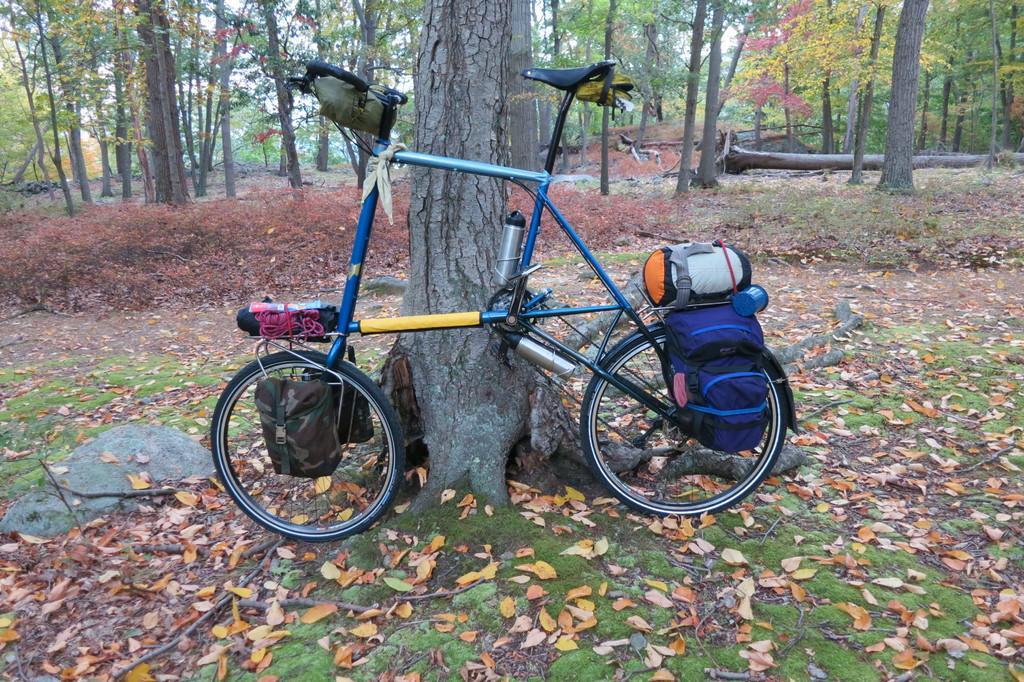Can you describe this image briefly? In this picture we can see a bicycle, couple of bottles and baggage, in the background we can find couple of trees. 